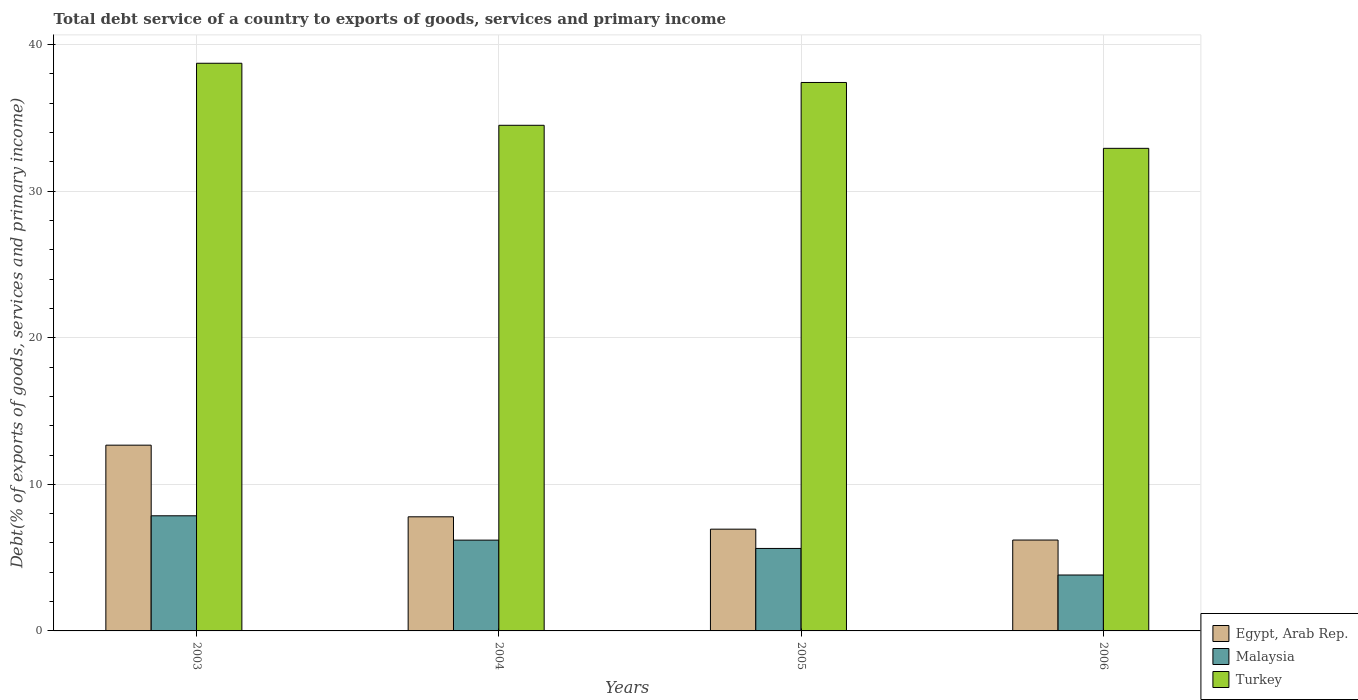How many different coloured bars are there?
Provide a short and direct response. 3. How many groups of bars are there?
Keep it short and to the point. 4. How many bars are there on the 4th tick from the left?
Your answer should be very brief. 3. What is the total debt service in Egypt, Arab Rep. in 2006?
Provide a short and direct response. 6.2. Across all years, what is the maximum total debt service in Malaysia?
Give a very brief answer. 7.85. Across all years, what is the minimum total debt service in Malaysia?
Offer a very short reply. 3.81. In which year was the total debt service in Turkey minimum?
Offer a very short reply. 2006. What is the total total debt service in Turkey in the graph?
Keep it short and to the point. 143.55. What is the difference between the total debt service in Malaysia in 2003 and that in 2005?
Give a very brief answer. 2.23. What is the difference between the total debt service in Malaysia in 2003 and the total debt service in Egypt, Arab Rep. in 2005?
Offer a terse response. 0.91. What is the average total debt service in Turkey per year?
Offer a terse response. 35.89. In the year 2006, what is the difference between the total debt service in Egypt, Arab Rep. and total debt service in Malaysia?
Make the answer very short. 2.39. What is the ratio of the total debt service in Turkey in 2003 to that in 2006?
Offer a very short reply. 1.18. Is the total debt service in Egypt, Arab Rep. in 2003 less than that in 2005?
Give a very brief answer. No. Is the difference between the total debt service in Egypt, Arab Rep. in 2004 and 2006 greater than the difference between the total debt service in Malaysia in 2004 and 2006?
Your answer should be compact. No. What is the difference between the highest and the second highest total debt service in Turkey?
Make the answer very short. 1.31. What is the difference between the highest and the lowest total debt service in Turkey?
Your response must be concise. 5.8. In how many years, is the total debt service in Egypt, Arab Rep. greater than the average total debt service in Egypt, Arab Rep. taken over all years?
Make the answer very short. 1. What does the 1st bar from the left in 2004 represents?
Keep it short and to the point. Egypt, Arab Rep. What does the 1st bar from the right in 2004 represents?
Make the answer very short. Turkey. Where does the legend appear in the graph?
Your response must be concise. Bottom right. What is the title of the graph?
Ensure brevity in your answer.  Total debt service of a country to exports of goods, services and primary income. Does "Least developed countries" appear as one of the legend labels in the graph?
Ensure brevity in your answer.  No. What is the label or title of the X-axis?
Give a very brief answer. Years. What is the label or title of the Y-axis?
Give a very brief answer. Debt(% of exports of goods, services and primary income). What is the Debt(% of exports of goods, services and primary income) of Egypt, Arab Rep. in 2003?
Make the answer very short. 12.67. What is the Debt(% of exports of goods, services and primary income) in Malaysia in 2003?
Your answer should be compact. 7.85. What is the Debt(% of exports of goods, services and primary income) in Turkey in 2003?
Your response must be concise. 38.72. What is the Debt(% of exports of goods, services and primary income) in Egypt, Arab Rep. in 2004?
Give a very brief answer. 7.78. What is the Debt(% of exports of goods, services and primary income) of Malaysia in 2004?
Your answer should be compact. 6.19. What is the Debt(% of exports of goods, services and primary income) of Turkey in 2004?
Your answer should be very brief. 34.49. What is the Debt(% of exports of goods, services and primary income) of Egypt, Arab Rep. in 2005?
Your response must be concise. 6.94. What is the Debt(% of exports of goods, services and primary income) in Malaysia in 2005?
Offer a terse response. 5.63. What is the Debt(% of exports of goods, services and primary income) of Turkey in 2005?
Make the answer very short. 37.41. What is the Debt(% of exports of goods, services and primary income) in Egypt, Arab Rep. in 2006?
Offer a terse response. 6.2. What is the Debt(% of exports of goods, services and primary income) of Malaysia in 2006?
Provide a succinct answer. 3.81. What is the Debt(% of exports of goods, services and primary income) of Turkey in 2006?
Your answer should be compact. 32.92. Across all years, what is the maximum Debt(% of exports of goods, services and primary income) of Egypt, Arab Rep.?
Your response must be concise. 12.67. Across all years, what is the maximum Debt(% of exports of goods, services and primary income) in Malaysia?
Provide a short and direct response. 7.85. Across all years, what is the maximum Debt(% of exports of goods, services and primary income) of Turkey?
Offer a terse response. 38.72. Across all years, what is the minimum Debt(% of exports of goods, services and primary income) of Egypt, Arab Rep.?
Provide a succinct answer. 6.2. Across all years, what is the minimum Debt(% of exports of goods, services and primary income) of Malaysia?
Keep it short and to the point. 3.81. Across all years, what is the minimum Debt(% of exports of goods, services and primary income) of Turkey?
Offer a very short reply. 32.92. What is the total Debt(% of exports of goods, services and primary income) of Egypt, Arab Rep. in the graph?
Give a very brief answer. 33.6. What is the total Debt(% of exports of goods, services and primary income) in Malaysia in the graph?
Make the answer very short. 23.49. What is the total Debt(% of exports of goods, services and primary income) in Turkey in the graph?
Make the answer very short. 143.55. What is the difference between the Debt(% of exports of goods, services and primary income) of Egypt, Arab Rep. in 2003 and that in 2004?
Ensure brevity in your answer.  4.89. What is the difference between the Debt(% of exports of goods, services and primary income) in Malaysia in 2003 and that in 2004?
Offer a very short reply. 1.66. What is the difference between the Debt(% of exports of goods, services and primary income) of Turkey in 2003 and that in 2004?
Ensure brevity in your answer.  4.23. What is the difference between the Debt(% of exports of goods, services and primary income) in Egypt, Arab Rep. in 2003 and that in 2005?
Your response must be concise. 5.73. What is the difference between the Debt(% of exports of goods, services and primary income) of Malaysia in 2003 and that in 2005?
Provide a succinct answer. 2.23. What is the difference between the Debt(% of exports of goods, services and primary income) in Turkey in 2003 and that in 2005?
Provide a succinct answer. 1.31. What is the difference between the Debt(% of exports of goods, services and primary income) in Egypt, Arab Rep. in 2003 and that in 2006?
Give a very brief answer. 6.47. What is the difference between the Debt(% of exports of goods, services and primary income) in Malaysia in 2003 and that in 2006?
Your response must be concise. 4.04. What is the difference between the Debt(% of exports of goods, services and primary income) of Turkey in 2003 and that in 2006?
Keep it short and to the point. 5.8. What is the difference between the Debt(% of exports of goods, services and primary income) in Egypt, Arab Rep. in 2004 and that in 2005?
Your response must be concise. 0.84. What is the difference between the Debt(% of exports of goods, services and primary income) in Malaysia in 2004 and that in 2005?
Offer a terse response. 0.57. What is the difference between the Debt(% of exports of goods, services and primary income) in Turkey in 2004 and that in 2005?
Provide a short and direct response. -2.92. What is the difference between the Debt(% of exports of goods, services and primary income) in Egypt, Arab Rep. in 2004 and that in 2006?
Your response must be concise. 1.58. What is the difference between the Debt(% of exports of goods, services and primary income) of Malaysia in 2004 and that in 2006?
Provide a succinct answer. 2.38. What is the difference between the Debt(% of exports of goods, services and primary income) in Turkey in 2004 and that in 2006?
Make the answer very short. 1.57. What is the difference between the Debt(% of exports of goods, services and primary income) of Egypt, Arab Rep. in 2005 and that in 2006?
Give a very brief answer. 0.74. What is the difference between the Debt(% of exports of goods, services and primary income) of Malaysia in 2005 and that in 2006?
Ensure brevity in your answer.  1.81. What is the difference between the Debt(% of exports of goods, services and primary income) of Turkey in 2005 and that in 2006?
Ensure brevity in your answer.  4.49. What is the difference between the Debt(% of exports of goods, services and primary income) in Egypt, Arab Rep. in 2003 and the Debt(% of exports of goods, services and primary income) in Malaysia in 2004?
Give a very brief answer. 6.48. What is the difference between the Debt(% of exports of goods, services and primary income) in Egypt, Arab Rep. in 2003 and the Debt(% of exports of goods, services and primary income) in Turkey in 2004?
Your answer should be compact. -21.82. What is the difference between the Debt(% of exports of goods, services and primary income) of Malaysia in 2003 and the Debt(% of exports of goods, services and primary income) of Turkey in 2004?
Provide a short and direct response. -26.64. What is the difference between the Debt(% of exports of goods, services and primary income) of Egypt, Arab Rep. in 2003 and the Debt(% of exports of goods, services and primary income) of Malaysia in 2005?
Keep it short and to the point. 7.04. What is the difference between the Debt(% of exports of goods, services and primary income) in Egypt, Arab Rep. in 2003 and the Debt(% of exports of goods, services and primary income) in Turkey in 2005?
Ensure brevity in your answer.  -24.74. What is the difference between the Debt(% of exports of goods, services and primary income) of Malaysia in 2003 and the Debt(% of exports of goods, services and primary income) of Turkey in 2005?
Provide a short and direct response. -29.56. What is the difference between the Debt(% of exports of goods, services and primary income) of Egypt, Arab Rep. in 2003 and the Debt(% of exports of goods, services and primary income) of Malaysia in 2006?
Keep it short and to the point. 8.86. What is the difference between the Debt(% of exports of goods, services and primary income) of Egypt, Arab Rep. in 2003 and the Debt(% of exports of goods, services and primary income) of Turkey in 2006?
Offer a terse response. -20.25. What is the difference between the Debt(% of exports of goods, services and primary income) in Malaysia in 2003 and the Debt(% of exports of goods, services and primary income) in Turkey in 2006?
Ensure brevity in your answer.  -25.07. What is the difference between the Debt(% of exports of goods, services and primary income) in Egypt, Arab Rep. in 2004 and the Debt(% of exports of goods, services and primary income) in Malaysia in 2005?
Your response must be concise. 2.16. What is the difference between the Debt(% of exports of goods, services and primary income) of Egypt, Arab Rep. in 2004 and the Debt(% of exports of goods, services and primary income) of Turkey in 2005?
Offer a terse response. -29.63. What is the difference between the Debt(% of exports of goods, services and primary income) of Malaysia in 2004 and the Debt(% of exports of goods, services and primary income) of Turkey in 2005?
Your answer should be very brief. -31.22. What is the difference between the Debt(% of exports of goods, services and primary income) in Egypt, Arab Rep. in 2004 and the Debt(% of exports of goods, services and primary income) in Malaysia in 2006?
Make the answer very short. 3.97. What is the difference between the Debt(% of exports of goods, services and primary income) of Egypt, Arab Rep. in 2004 and the Debt(% of exports of goods, services and primary income) of Turkey in 2006?
Keep it short and to the point. -25.14. What is the difference between the Debt(% of exports of goods, services and primary income) in Malaysia in 2004 and the Debt(% of exports of goods, services and primary income) in Turkey in 2006?
Your answer should be very brief. -26.73. What is the difference between the Debt(% of exports of goods, services and primary income) of Egypt, Arab Rep. in 2005 and the Debt(% of exports of goods, services and primary income) of Malaysia in 2006?
Offer a terse response. 3.13. What is the difference between the Debt(% of exports of goods, services and primary income) of Egypt, Arab Rep. in 2005 and the Debt(% of exports of goods, services and primary income) of Turkey in 2006?
Make the answer very short. -25.98. What is the difference between the Debt(% of exports of goods, services and primary income) in Malaysia in 2005 and the Debt(% of exports of goods, services and primary income) in Turkey in 2006?
Your response must be concise. -27.29. What is the average Debt(% of exports of goods, services and primary income) of Egypt, Arab Rep. per year?
Your answer should be compact. 8.4. What is the average Debt(% of exports of goods, services and primary income) in Malaysia per year?
Ensure brevity in your answer.  5.87. What is the average Debt(% of exports of goods, services and primary income) in Turkey per year?
Offer a terse response. 35.89. In the year 2003, what is the difference between the Debt(% of exports of goods, services and primary income) of Egypt, Arab Rep. and Debt(% of exports of goods, services and primary income) of Malaysia?
Your answer should be very brief. 4.82. In the year 2003, what is the difference between the Debt(% of exports of goods, services and primary income) of Egypt, Arab Rep. and Debt(% of exports of goods, services and primary income) of Turkey?
Give a very brief answer. -26.05. In the year 2003, what is the difference between the Debt(% of exports of goods, services and primary income) of Malaysia and Debt(% of exports of goods, services and primary income) of Turkey?
Your response must be concise. -30.87. In the year 2004, what is the difference between the Debt(% of exports of goods, services and primary income) in Egypt, Arab Rep. and Debt(% of exports of goods, services and primary income) in Malaysia?
Offer a very short reply. 1.59. In the year 2004, what is the difference between the Debt(% of exports of goods, services and primary income) of Egypt, Arab Rep. and Debt(% of exports of goods, services and primary income) of Turkey?
Provide a succinct answer. -26.71. In the year 2004, what is the difference between the Debt(% of exports of goods, services and primary income) in Malaysia and Debt(% of exports of goods, services and primary income) in Turkey?
Your response must be concise. -28.3. In the year 2005, what is the difference between the Debt(% of exports of goods, services and primary income) of Egypt, Arab Rep. and Debt(% of exports of goods, services and primary income) of Malaysia?
Offer a terse response. 1.32. In the year 2005, what is the difference between the Debt(% of exports of goods, services and primary income) of Egypt, Arab Rep. and Debt(% of exports of goods, services and primary income) of Turkey?
Ensure brevity in your answer.  -30.47. In the year 2005, what is the difference between the Debt(% of exports of goods, services and primary income) of Malaysia and Debt(% of exports of goods, services and primary income) of Turkey?
Give a very brief answer. -31.79. In the year 2006, what is the difference between the Debt(% of exports of goods, services and primary income) in Egypt, Arab Rep. and Debt(% of exports of goods, services and primary income) in Malaysia?
Provide a short and direct response. 2.39. In the year 2006, what is the difference between the Debt(% of exports of goods, services and primary income) of Egypt, Arab Rep. and Debt(% of exports of goods, services and primary income) of Turkey?
Your answer should be compact. -26.72. In the year 2006, what is the difference between the Debt(% of exports of goods, services and primary income) of Malaysia and Debt(% of exports of goods, services and primary income) of Turkey?
Make the answer very short. -29.11. What is the ratio of the Debt(% of exports of goods, services and primary income) in Egypt, Arab Rep. in 2003 to that in 2004?
Provide a succinct answer. 1.63. What is the ratio of the Debt(% of exports of goods, services and primary income) of Malaysia in 2003 to that in 2004?
Make the answer very short. 1.27. What is the ratio of the Debt(% of exports of goods, services and primary income) of Turkey in 2003 to that in 2004?
Provide a short and direct response. 1.12. What is the ratio of the Debt(% of exports of goods, services and primary income) in Egypt, Arab Rep. in 2003 to that in 2005?
Give a very brief answer. 1.83. What is the ratio of the Debt(% of exports of goods, services and primary income) of Malaysia in 2003 to that in 2005?
Keep it short and to the point. 1.4. What is the ratio of the Debt(% of exports of goods, services and primary income) of Turkey in 2003 to that in 2005?
Keep it short and to the point. 1.03. What is the ratio of the Debt(% of exports of goods, services and primary income) in Egypt, Arab Rep. in 2003 to that in 2006?
Ensure brevity in your answer.  2.04. What is the ratio of the Debt(% of exports of goods, services and primary income) in Malaysia in 2003 to that in 2006?
Your answer should be very brief. 2.06. What is the ratio of the Debt(% of exports of goods, services and primary income) of Turkey in 2003 to that in 2006?
Your answer should be compact. 1.18. What is the ratio of the Debt(% of exports of goods, services and primary income) of Egypt, Arab Rep. in 2004 to that in 2005?
Offer a terse response. 1.12. What is the ratio of the Debt(% of exports of goods, services and primary income) in Malaysia in 2004 to that in 2005?
Provide a short and direct response. 1.1. What is the ratio of the Debt(% of exports of goods, services and primary income) in Turkey in 2004 to that in 2005?
Provide a short and direct response. 0.92. What is the ratio of the Debt(% of exports of goods, services and primary income) in Egypt, Arab Rep. in 2004 to that in 2006?
Offer a very short reply. 1.26. What is the ratio of the Debt(% of exports of goods, services and primary income) in Malaysia in 2004 to that in 2006?
Make the answer very short. 1.62. What is the ratio of the Debt(% of exports of goods, services and primary income) of Turkey in 2004 to that in 2006?
Give a very brief answer. 1.05. What is the ratio of the Debt(% of exports of goods, services and primary income) of Egypt, Arab Rep. in 2005 to that in 2006?
Offer a terse response. 1.12. What is the ratio of the Debt(% of exports of goods, services and primary income) of Malaysia in 2005 to that in 2006?
Make the answer very short. 1.48. What is the ratio of the Debt(% of exports of goods, services and primary income) in Turkey in 2005 to that in 2006?
Give a very brief answer. 1.14. What is the difference between the highest and the second highest Debt(% of exports of goods, services and primary income) in Egypt, Arab Rep.?
Give a very brief answer. 4.89. What is the difference between the highest and the second highest Debt(% of exports of goods, services and primary income) of Malaysia?
Make the answer very short. 1.66. What is the difference between the highest and the second highest Debt(% of exports of goods, services and primary income) in Turkey?
Make the answer very short. 1.31. What is the difference between the highest and the lowest Debt(% of exports of goods, services and primary income) of Egypt, Arab Rep.?
Provide a succinct answer. 6.47. What is the difference between the highest and the lowest Debt(% of exports of goods, services and primary income) of Malaysia?
Provide a succinct answer. 4.04. What is the difference between the highest and the lowest Debt(% of exports of goods, services and primary income) in Turkey?
Provide a short and direct response. 5.8. 